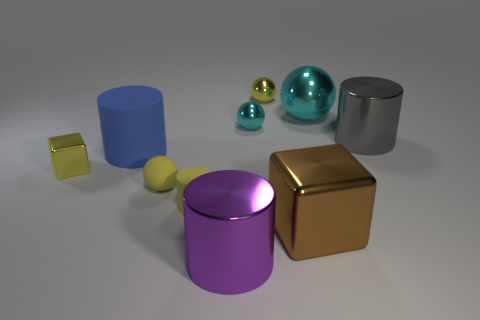Can you describe the shapes and their colors in the image? Certainly! The image contains a variety of geometric shapes including a small yellow cube, a larger gold cube, a purple cylinder, a blue cylinder, a silver cylinder with a reflective surface, and a couple of spheres in two different sizes - one small yellow and one larger teal, both with shiny surfaces. 